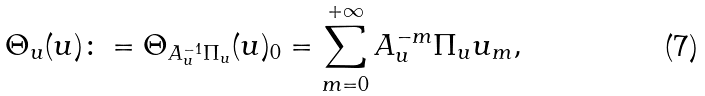<formula> <loc_0><loc_0><loc_500><loc_500>\Theta _ { u } ( u ) \colon = \Theta _ { A _ { u } ^ { - 1 } \Pi _ { u } } ( u ) _ { 0 } = \sum _ { m = 0 } ^ { + \infty } A _ { u } ^ { - m } \Pi _ { u } u _ { m } ,</formula> 